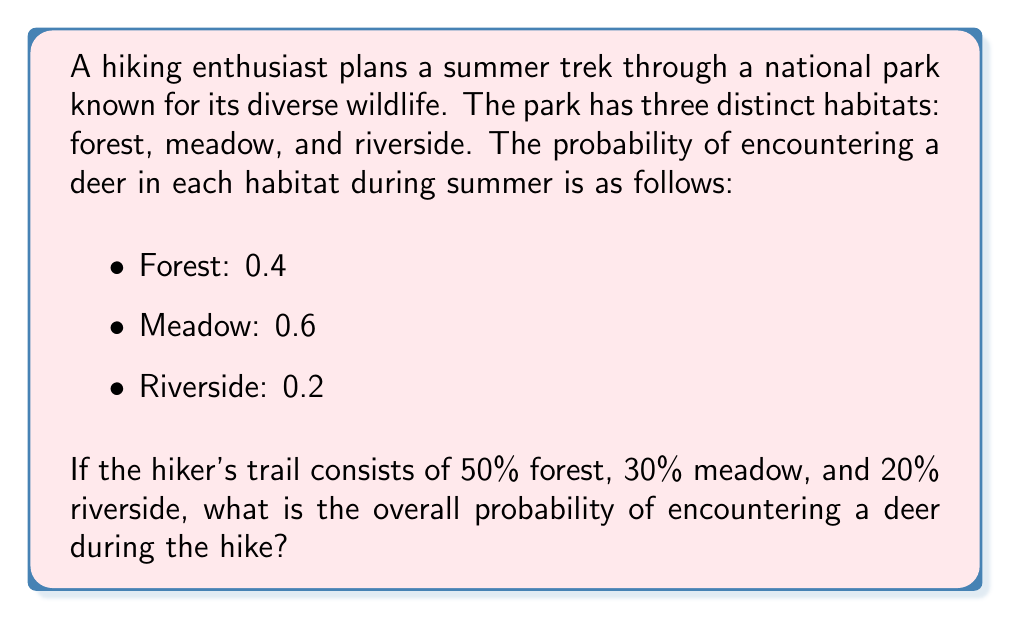Can you solve this math problem? To solve this problem, we'll use the law of total probability. Let's break it down step-by-step:

1) Let D be the event of encountering a deer, and F, M, R be the events of being in the forest, meadow, and riverside respectively.

2) We're given:
   $P(D|F) = 0.4$
   $P(D|M) = 0.6$
   $P(D|R) = 0.2$
   $P(F) = 0.5$
   $P(M) = 0.3$
   $P(R) = 0.2$

3) The law of total probability states:
   $P(D) = P(D|F)P(F) + P(D|M)P(M) + P(D|R)P(R)$

4) Let's substitute the values:
   $P(D) = (0.4)(0.5) + (0.6)(0.3) + (0.2)(0.2)$

5) Now, let's calculate:
   $P(D) = 0.2 + 0.18 + 0.04$

6) Adding these up:
   $P(D) = 0.42$

Therefore, the overall probability of encountering a deer during the hike is 0.42 or 42%.
Answer: 0.42 